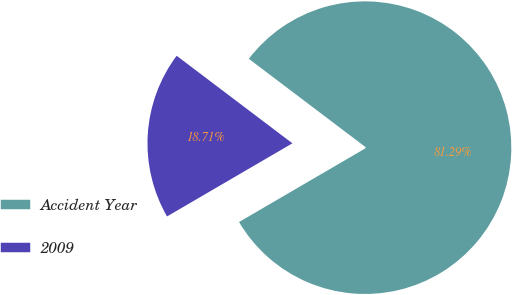Convert chart to OTSL. <chart><loc_0><loc_0><loc_500><loc_500><pie_chart><fcel>Accident Year<fcel>2009<nl><fcel>81.29%<fcel>18.71%<nl></chart> 